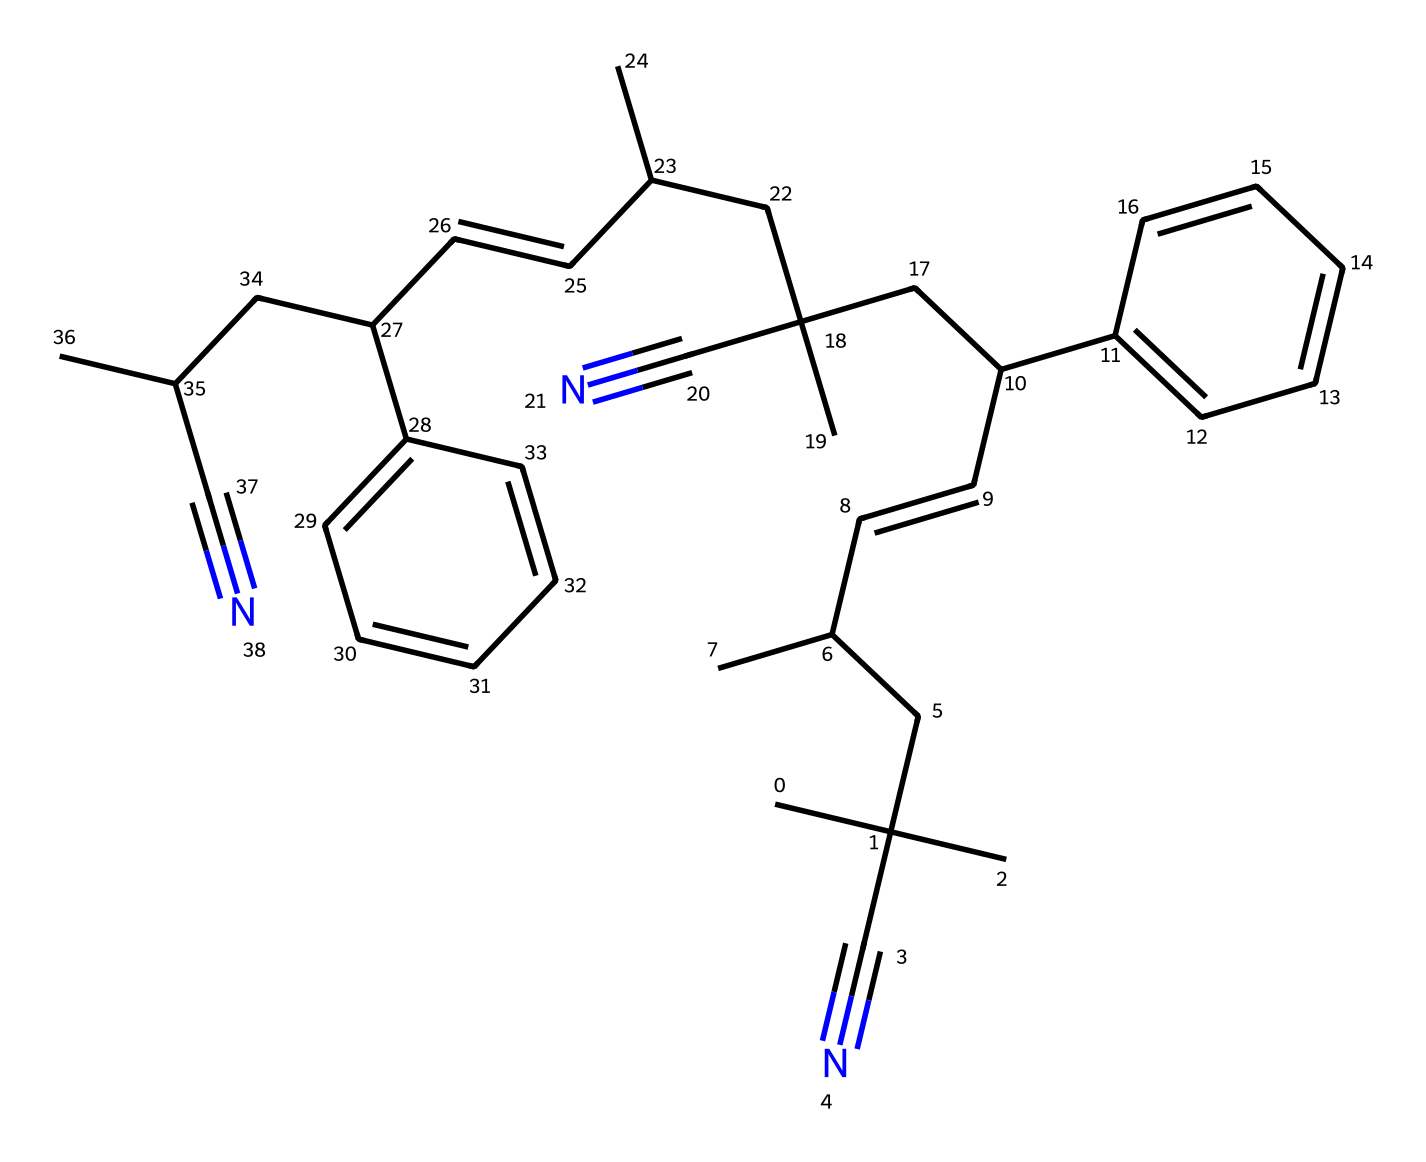What is the main functional group in acrylonitrile butadiene styrene? The chemical structure contains a cyano (-C≡N) functional group, which is identified by the presence of the carbon triple-bonded to a nitrogen atom.
Answer: cyano How many distinct carbon atoms are present in the polymer structure of ABS? By analyzing the structure, one can count the number of unique carbon atoms which, upon examination, leads to a total of 30 carbon atoms.
Answer: 30 What is the general polymer type of acrylonitrile butadiene styrene? The polymer structure is a type of thermoplastic, which can be determined from its long-chain structure and the presence of distinct monomer units.
Answer: thermoplastic How many aromatic rings are present in the structure of ABS? The structure displays two phenyl groups, which are recognized as distinct aromatic rings attached to the polymer backbone.
Answer: 2 What characteristic of ABS contributes to its impact resistance? The presence of the butadiene component in the polymer structure provides rubbery properties, enhancing impact resistance in the material.
Answer: butadiene Which property is primarily enhanced by the acrylonitrile component of ABS? The acrylonitrile portion of ABS contributes to increased chemical resistance and toughness, evaluated based on the polar nature of the cyano groups in the molecule.
Answer: chemical resistance 